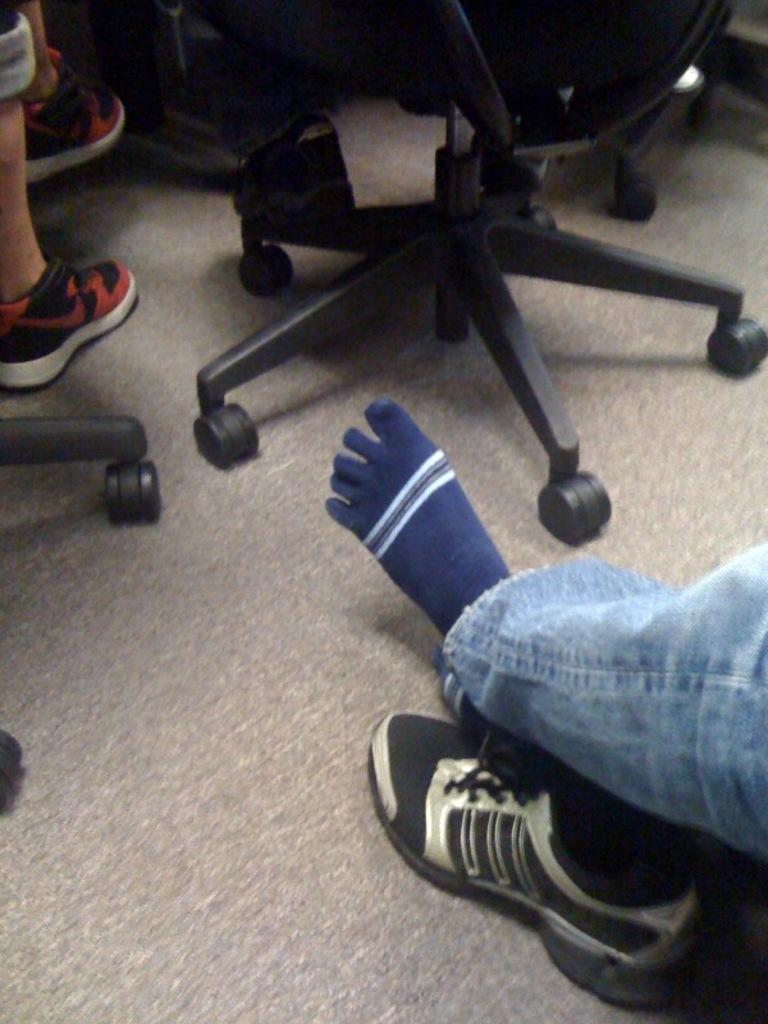How many chairs are present in the image? There are two chairs in the image. What can be inferred about the presence of people in the image? Two persons' legs are visible in the image, suggesting that there are people sitting on the chairs. What type of cabbage is being used as a tablecloth in the image? There is no cabbage present in the image, nor is it being used as a tablecloth. 